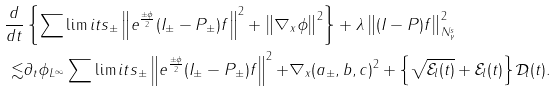<formula> <loc_0><loc_0><loc_500><loc_500>\frac { d } { d t } & \left \{ \sum \lim i t s _ { \pm } \left \| e ^ { \frac { \pm \phi } { 2 } } ( { I } _ { \pm } - { P } _ { \pm } ) f \right \| ^ { 2 } + \left \| \nabla _ { x } \phi \right \| ^ { 2 } \right \} + \lambda \left \| ( { I } - { P } ) f \right \| ^ { 2 } _ { N ^ { s } _ { \gamma } } \\ \lesssim & \| \partial _ { t } \phi \| _ { L ^ { \infty } } \sum \lim i t s _ { \pm } \left \| e ^ { \frac { \pm \phi } { 2 } } ( { I } _ { \pm } - { P } _ { \pm } ) f \right \| ^ { 2 } { + \| \nabla _ { x } ( a _ { \pm } , b , c ) \| ^ { 2 } } + \left \{ \sqrt { \mathcal { E } _ { l } ( t ) } + \mathcal { E } _ { l } ( t ) \right \} \mathcal { D } _ { l } ( t ) .</formula> 